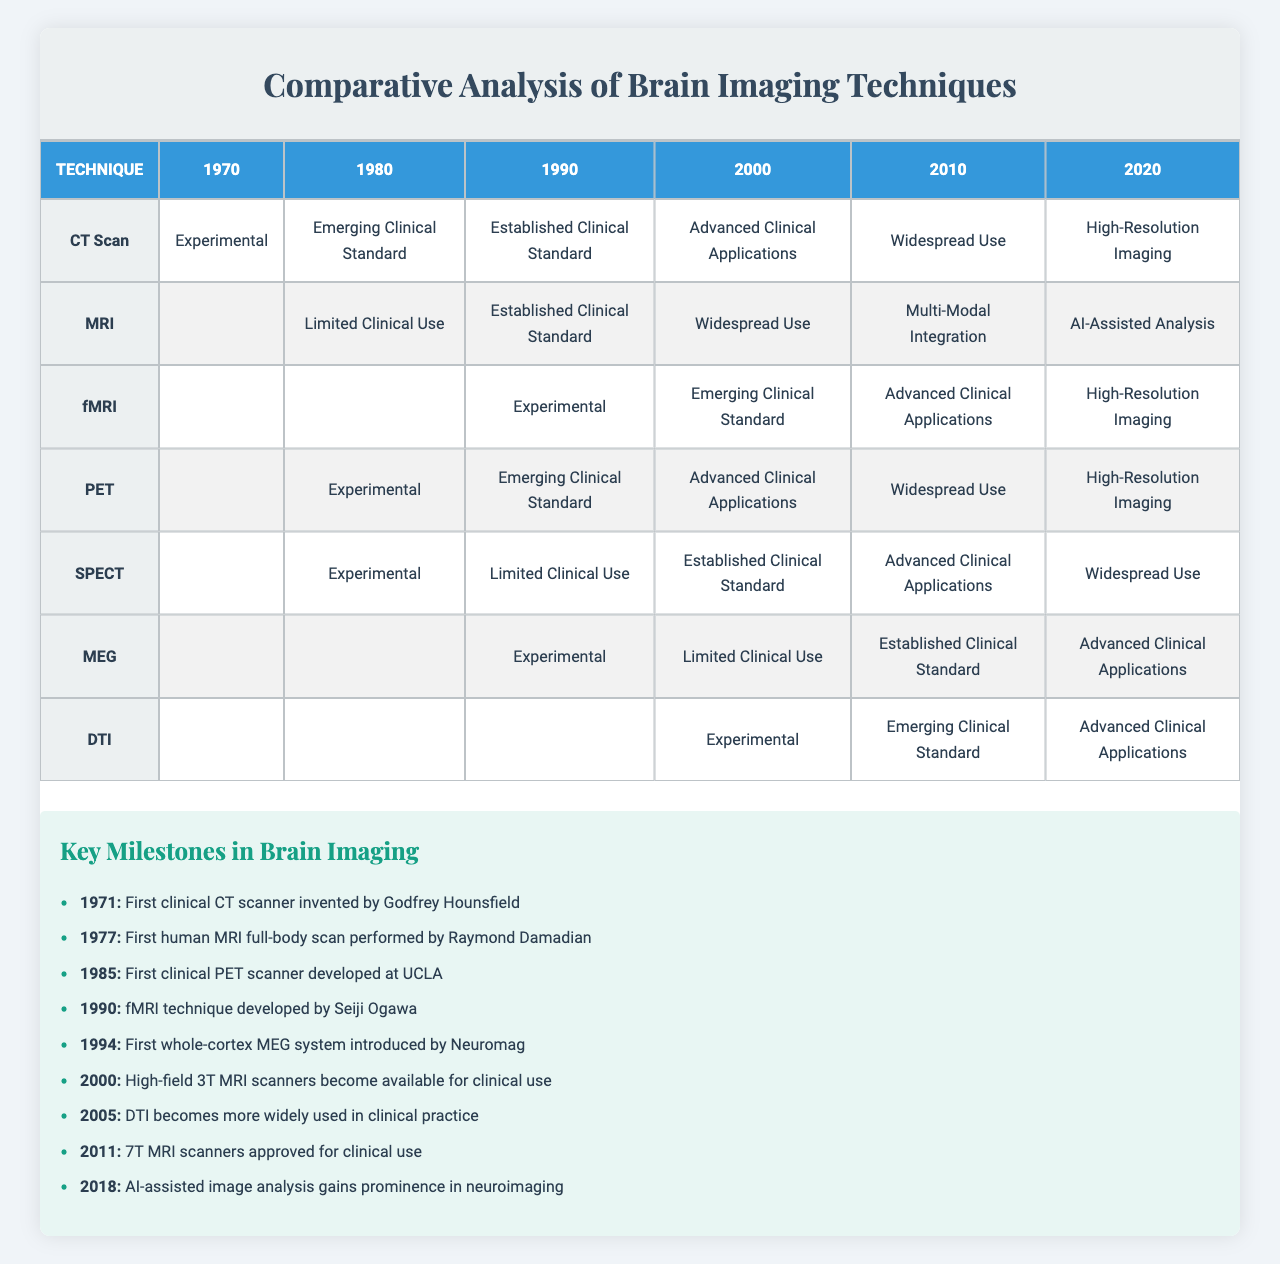What was the technique with the highest status in 2020? In 2020, the metric for CT Scan was "High-Resolution Imaging" (7), and for MRI, it was "AI-Assisted Analysis" (9). Among them, MRI has the highest status.
Answer: MRI How many imaging techniques had a metric of "Established Clinical Standard" in the year 2000? In 2000, both CT Scan and PET had a metric labeled as "Established Clinical Standard" (4). Therefore, there are 2 techniques.
Answer: 2 What technique first appeared in 1980? The techniques that appeared in 1980 are CT Scan, MRI, PET, and SPECT. This includes 4 techniques.
Answer: 4 What is the average status for techniques available in 2010? The metrics for 2010 are as follows: CT Scan (6), MRI (8), fMRI (5), PET (6), SPECT (5), MEG (4), DTI (3). The average is calculated by summing these values (6 + 8 + 5 + 6 + 5 + 4 + 3) = 37. Dividing by the number of techniques (7) gives an average of approximately 5.29.
Answer: 5.29 Did MEG have a presence in the table before 1990? MEG first appeared in 1990, meaning it did not have any presence in the table before that year. Therefore, the answer is No.
Answer: No Which technique showed the least improvement from 2000 to 2020? Analyzing the metrics for each technique in 2000 and 2020: CT Scan (5 to 7), MRI (6 to 9), fMRI (3 to 7), PET (5 to 7), SPECT (4 to 6), MEG (2 to 5), DTI (1 to 5). The least improvement (from 4 to 6) belongs to SPECT.
Answer: SPECT What was the highest metric achieved by DTI? DTI achieved a maximum metric of "Advanced Clinical Applications" (5) in 2010 and 2020.
Answer: 5 Which technique entered clinical use in the year 1977? The technique that first achieved clinical use in 1977 is MRI, as noted in the key milestones.
Answer: MRI What is the difference in metrics between CT Scan and PET in 2020? In 2020, CT Scan had a metric of 7 and PET had a metric of 7 as well. Therefore, the difference is 7 - 7 = 0.
Answer: 0 How many techniques achieved "Widespread Use" (6) in the year 2010? In 2010, the techniques that had a metric of "Widespread Use" were CT Scan, PET, and SPECT, totaling 3 techniques.
Answer: 3 